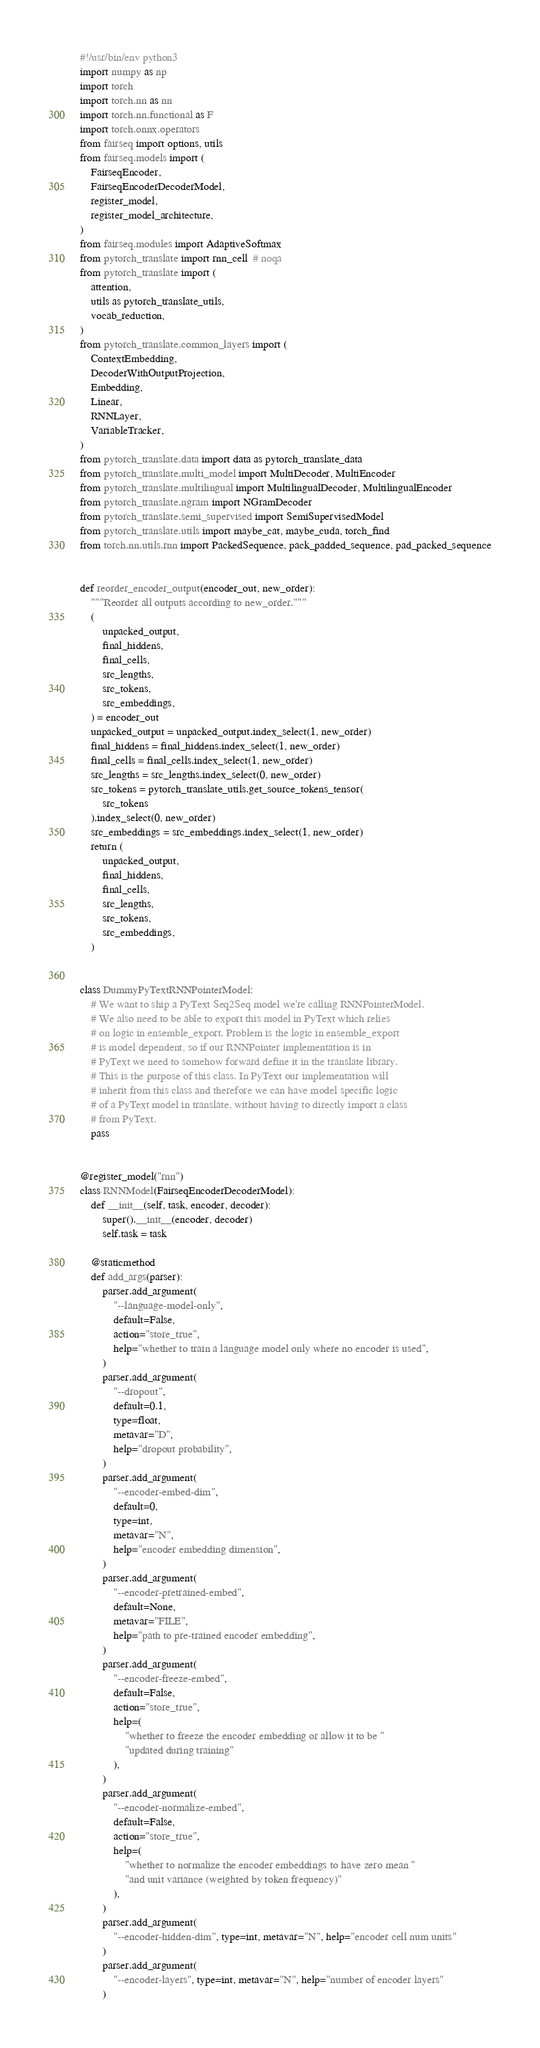Convert code to text. <code><loc_0><loc_0><loc_500><loc_500><_Python_>#!/usr/bin/env python3
import numpy as np
import torch
import torch.nn as nn
import torch.nn.functional as F
import torch.onnx.operators
from fairseq import options, utils
from fairseq.models import (
    FairseqEncoder,
    FairseqEncoderDecoderModel,
    register_model,
    register_model_architecture,
)
from fairseq.modules import AdaptiveSoftmax
from pytorch_translate import rnn_cell  # noqa
from pytorch_translate import (
    attention,
    utils as pytorch_translate_utils,
    vocab_reduction,
)
from pytorch_translate.common_layers import (
    ContextEmbedding,
    DecoderWithOutputProjection,
    Embedding,
    Linear,
    RNNLayer,
    VariableTracker,
)
from pytorch_translate.data import data as pytorch_translate_data
from pytorch_translate.multi_model import MultiDecoder, MultiEncoder
from pytorch_translate.multilingual import MultilingualDecoder, MultilingualEncoder
from pytorch_translate.ngram import NGramDecoder
from pytorch_translate.semi_supervised import SemiSupervisedModel
from pytorch_translate.utils import maybe_cat, maybe_cuda, torch_find
from torch.nn.utils.rnn import PackedSequence, pack_padded_sequence, pad_packed_sequence


def reorder_encoder_output(encoder_out, new_order):
    """Reorder all outputs according to new_order."""
    (
        unpacked_output,
        final_hiddens,
        final_cells,
        src_lengths,
        src_tokens,
        src_embeddings,
    ) = encoder_out
    unpacked_output = unpacked_output.index_select(1, new_order)
    final_hiddens = final_hiddens.index_select(1, new_order)
    final_cells = final_cells.index_select(1, new_order)
    src_lengths = src_lengths.index_select(0, new_order)
    src_tokens = pytorch_translate_utils.get_source_tokens_tensor(
        src_tokens
    ).index_select(0, new_order)
    src_embeddings = src_embeddings.index_select(1, new_order)
    return (
        unpacked_output,
        final_hiddens,
        final_cells,
        src_lengths,
        src_tokens,
        src_embeddings,
    )


class DummyPyTextRNNPointerModel:
    # We want to ship a PyText Seq2Seq model we're calling RNNPointerModel.
    # We also need to be able to export this model in PyText which relies
    # on logic in ensemble_export. Problem is the logic in ensemble_export
    # is model dependent, so if our RNNPointer implementation is in
    # PyText we need to somehow forward define it in the translate library.
    # This is the purpose of this class. In PyText our implementation will
    # inherit from this class and therefore we can have model specific logic
    # of a PyText model in translate, without having to directly import a class
    # from PyText.
    pass


@register_model("rnn")
class RNNModel(FairseqEncoderDecoderModel):
    def __init__(self, task, encoder, decoder):
        super().__init__(encoder, decoder)
        self.task = task

    @staticmethod
    def add_args(parser):
        parser.add_argument(
            "--language-model-only",
            default=False,
            action="store_true",
            help="whether to train a language model only where no encoder is used",
        )
        parser.add_argument(
            "--dropout",
            default=0.1,
            type=float,
            metavar="D",
            help="dropout probability",
        )
        parser.add_argument(
            "--encoder-embed-dim",
            default=0,
            type=int,
            metavar="N",
            help="encoder embedding dimension",
        )
        parser.add_argument(
            "--encoder-pretrained-embed",
            default=None,
            metavar="FILE",
            help="path to pre-trained encoder embedding",
        )
        parser.add_argument(
            "--encoder-freeze-embed",
            default=False,
            action="store_true",
            help=(
                "whether to freeze the encoder embedding or allow it to be "
                "updated during training"
            ),
        )
        parser.add_argument(
            "--encoder-normalize-embed",
            default=False,
            action="store_true",
            help=(
                "whether to normalize the encoder embeddings to have zero mean "
                "and unit variance (weighted by token frequency)"
            ),
        )
        parser.add_argument(
            "--encoder-hidden-dim", type=int, metavar="N", help="encoder cell num units"
        )
        parser.add_argument(
            "--encoder-layers", type=int, metavar="N", help="number of encoder layers"
        )</code> 